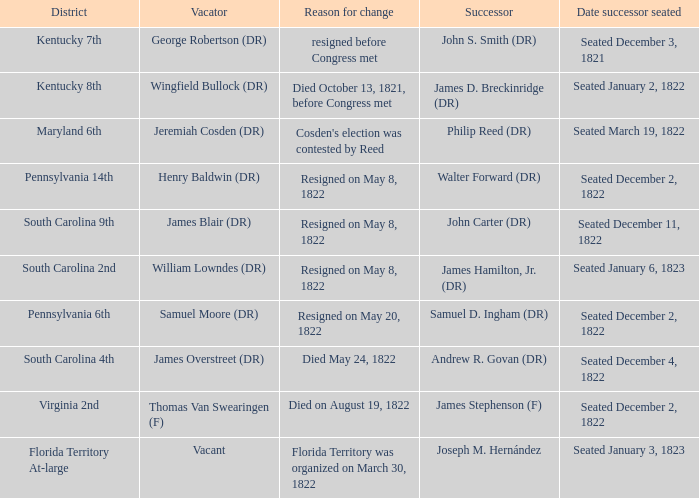Who is the person relinquishing when south carolina 4th is the district? James Overstreet (DR). Give me the full table as a dictionary. {'header': ['District', 'Vacator', 'Reason for change', 'Successor', 'Date successor seated'], 'rows': [['Kentucky 7th', 'George Robertson (DR)', 'resigned before Congress met', 'John S. Smith (DR)', 'Seated December 3, 1821'], ['Kentucky 8th', 'Wingfield Bullock (DR)', 'Died October 13, 1821, before Congress met', 'James D. Breckinridge (DR)', 'Seated January 2, 1822'], ['Maryland 6th', 'Jeremiah Cosden (DR)', "Cosden's election was contested by Reed", 'Philip Reed (DR)', 'Seated March 19, 1822'], ['Pennsylvania 14th', 'Henry Baldwin (DR)', 'Resigned on May 8, 1822', 'Walter Forward (DR)', 'Seated December 2, 1822'], ['South Carolina 9th', 'James Blair (DR)', 'Resigned on May 8, 1822', 'John Carter (DR)', 'Seated December 11, 1822'], ['South Carolina 2nd', 'William Lowndes (DR)', 'Resigned on May 8, 1822', 'James Hamilton, Jr. (DR)', 'Seated January 6, 1823'], ['Pennsylvania 6th', 'Samuel Moore (DR)', 'Resigned on May 20, 1822', 'Samuel D. Ingham (DR)', 'Seated December 2, 1822'], ['South Carolina 4th', 'James Overstreet (DR)', 'Died May 24, 1822', 'Andrew R. Govan (DR)', 'Seated December 4, 1822'], ['Virginia 2nd', 'Thomas Van Swearingen (F)', 'Died on August 19, 1822', 'James Stephenson (F)', 'Seated December 2, 1822'], ['Florida Territory At-large', 'Vacant', 'Florida Territory was organized on March 30, 1822', 'Joseph M. Hernández', 'Seated January 3, 1823']]} 